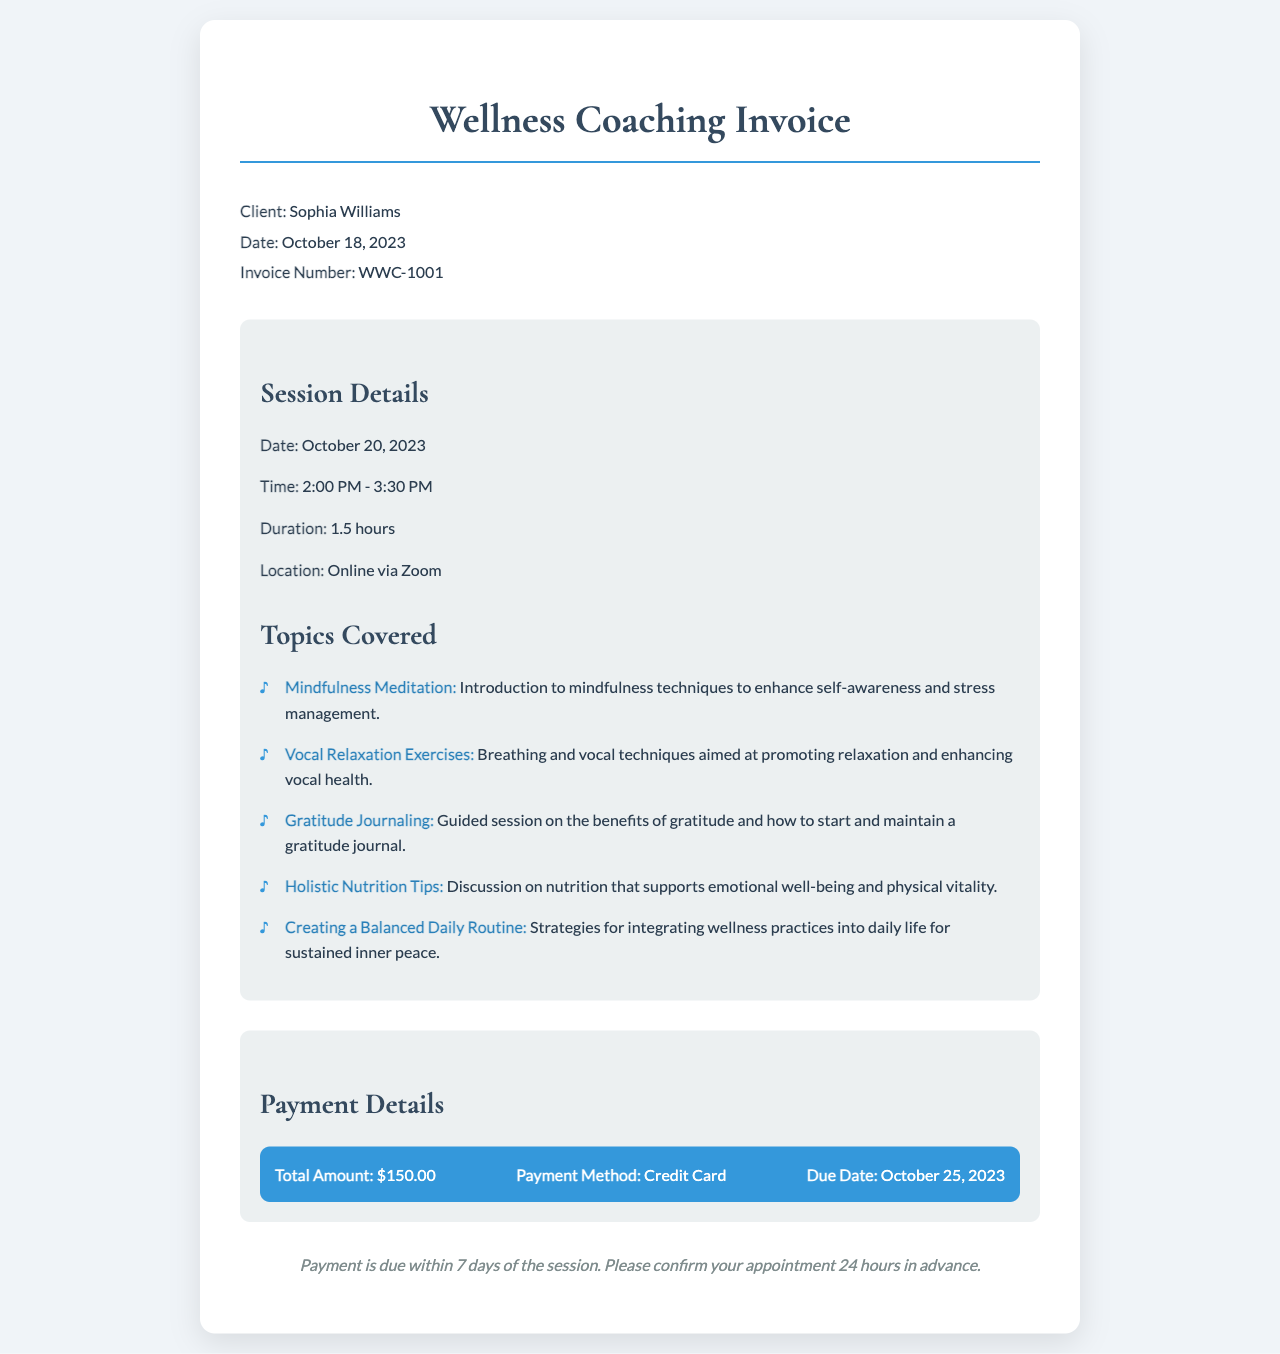What is the client's name? The document lists the client's name as Sophia Williams.
Answer: Sophia Williams What is the total amount due? The total amount due for the wellness coaching session is specified in the payment details section.
Answer: $150.00 When is the session scheduled? The date of the session is mentioned in the session details section, which states October 20, 2023.
Answer: October 20, 2023 What topics are covered in the session? The document includes a list of topics covered during the session such as mindfulness meditation and vocal relaxation exercises, highlighting the focus areas.
Answer: Mindfulness Meditation, Vocal Relaxation Exercises, Gratitude Journaling, Holistic Nutrition Tips, Creating a Balanced Daily Routine How long is the session scheduled to last? The duration of the session is explicitly stated as 1.5 hours in the session details.
Answer: 1.5 hours What payment method is indicated? The payment method used for this session is specified in the payment details section.
Answer: Credit Card When is the payment due? The due date for the payment is mentioned in the payment details section as October 25, 2023.
Answer: October 25, 2023 What is the session location? The document specifies that the session will take place online via Zoom, which is noted in the session details.
Answer: Online via Zoom 